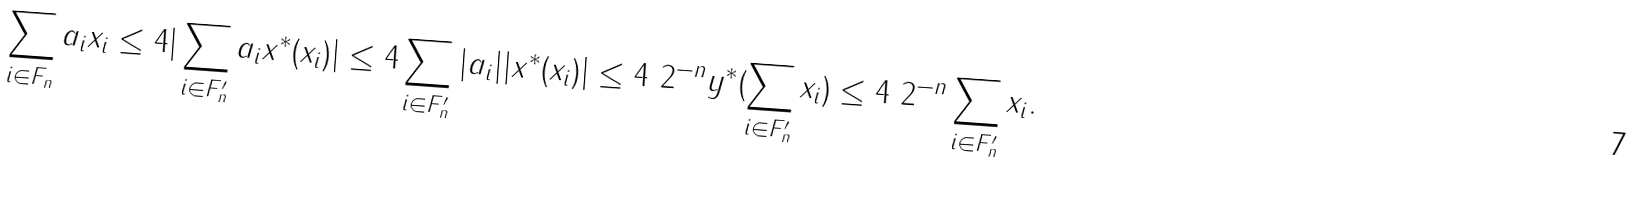<formula> <loc_0><loc_0><loc_500><loc_500>\| \sum _ { i \in F _ { n } } a _ { i } x _ { i } \| \leq 4 | \sum _ { i \in F _ { n } ^ { \prime } } a _ { i } x ^ { * } ( x _ { i } ) | \leq 4 \sum _ { i \in F _ { n } ^ { \prime } } | a _ { i } | | x ^ { * } ( x _ { i } ) | \leq 4 \ 2 ^ { - n } y ^ { * } ( \sum _ { i \in F _ { n } ^ { \prime } } x _ { i } ) \leq 4 \ 2 ^ { - n } \| \sum _ { i \in F _ { n } ^ { \prime } } x _ { i } \| .</formula> 